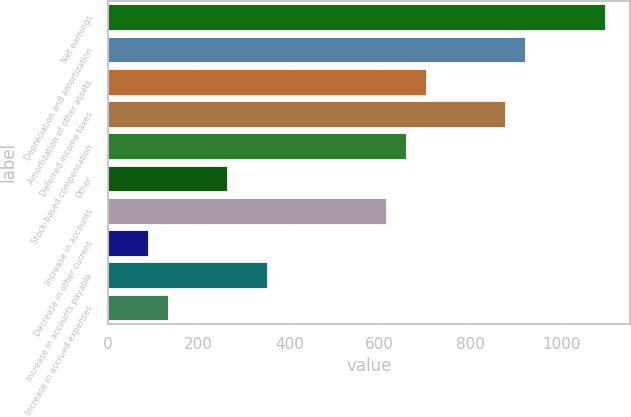Convert chart. <chart><loc_0><loc_0><loc_500><loc_500><bar_chart><fcel>Net earnings<fcel>Depreciation and amortization<fcel>Amortization of other assets<fcel>Deferred income taxes<fcel>Stock-based compensation<fcel>Other<fcel>Increase in accounts<fcel>Decrease in other current<fcel>Increase in accounts payable<fcel>Increase in accrued expenses<nl><fcel>1096.2<fcel>920.84<fcel>701.64<fcel>877<fcel>657.8<fcel>263.24<fcel>613.96<fcel>87.88<fcel>350.92<fcel>131.72<nl></chart> 